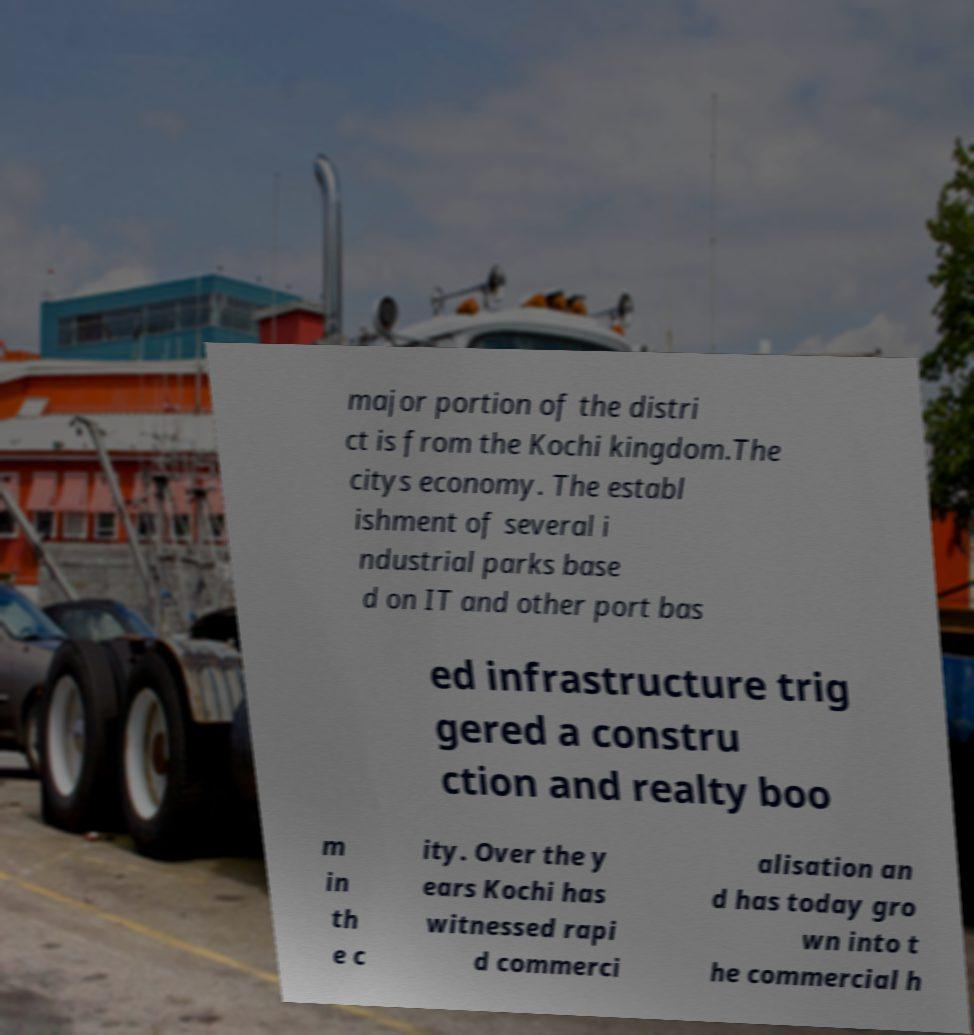Could you assist in decoding the text presented in this image and type it out clearly? major portion of the distri ct is from the Kochi kingdom.The citys economy. The establ ishment of several i ndustrial parks base d on IT and other port bas ed infrastructure trig gered a constru ction and realty boo m in th e c ity. Over the y ears Kochi has witnessed rapi d commerci alisation an d has today gro wn into t he commercial h 